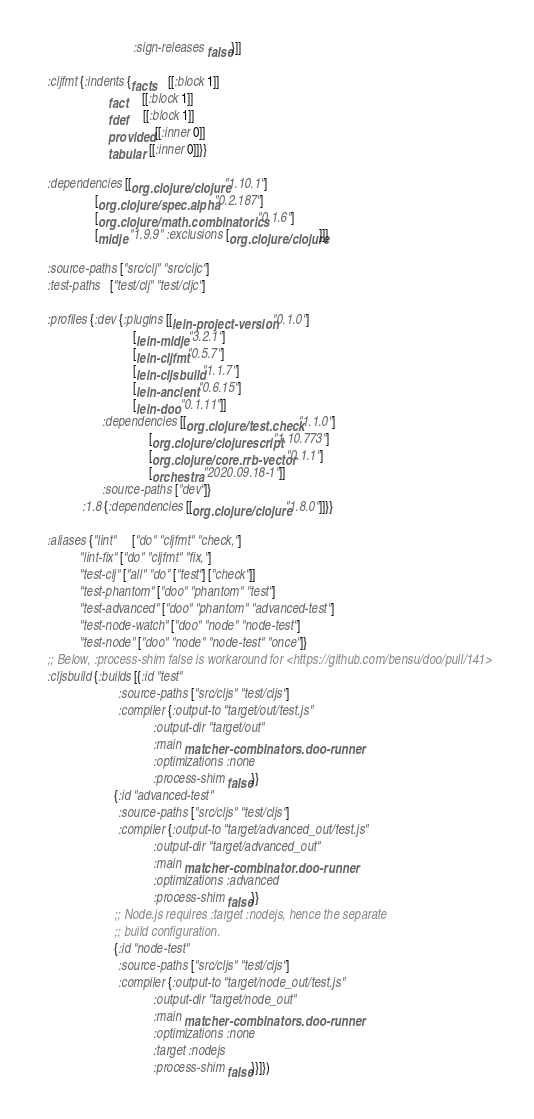Convert code to text. <code><loc_0><loc_0><loc_500><loc_500><_Clojure_>                             :sign-releases false}]]

  :cljfmt {:indents {facts    [[:block 1]]
                     fact     [[:block 1]]
                     fdef     [[:block 1]]
                     provided [[:inner 0]]
                     tabular  [[:inner 0]]}}

  :dependencies [[org.clojure/clojure "1.10.1"]
                 [org.clojure/spec.alpha "0.2.187"]
                 [org.clojure/math.combinatorics "0.1.6"]
                 [midje "1.9.9" :exclusions [org.clojure/clojure]]]

  :source-paths ["src/clj" "src/cljc"]
  :test-paths   ["test/clj" "test/cljc"]

  :profiles {:dev {:plugins [[lein-project-version "0.1.0"]
                             [lein-midje "3.2.1"]
                             [lein-cljfmt "0.5.7"]
                             [lein-cljsbuild "1.1.7"]
                             [lein-ancient "0.6.15"]
                             [lein-doo "0.1.11"]]
                   :dependencies [[org.clojure/test.check "1.1.0"]
                                  [org.clojure/clojurescript "1.10.773"]
                                  [org.clojure/core.rrb-vector "0.1.1"]
                                  [orchestra "2020.09.18-1"]]
                   :source-paths ["dev"]}
             :1.8 {:dependencies [[org.clojure/clojure "1.8.0"]]}}

  :aliases {"lint"     ["do" "cljfmt" "check,"]
            "lint-fix" ["do" "cljfmt" "fix,"]
            "test-clj" ["all" "do" ["test"] ["check"]]
            "test-phantom" ["doo" "phantom" "test"]
            "test-advanced" ["doo" "phantom" "advanced-test"]
            "test-node-watch" ["doo" "node" "node-test"]
            "test-node" ["doo" "node" "node-test" "once"]}
  ;; Below, :process-shim false is workaround for <https://github.com/bensu/doo/pull/141>
  :cljsbuild {:builds [{:id "test"
                        :source-paths ["src/cljs" "test/cljs"]
                        :compiler {:output-to "target/out/test.js"
                                   :output-dir "target/out"
                                   :main matcher-combinators.doo-runner
                                   :optimizations :none
                                   :process-shim false}}
                       {:id "advanced-test"
                        :source-paths ["src/cljs" "test/cljs"]
                        :compiler {:output-to "target/advanced_out/test.js"
                                   :output-dir "target/advanced_out"
                                   :main matcher-combinator.doo-runner
                                   :optimizations :advanced
                                   :process-shim false}}
                       ;; Node.js requires :target :nodejs, hence the separate
                       ;; build configuration.
                       {:id "node-test"
                        :source-paths ["src/cljs" "test/cljs"]
                        :compiler {:output-to "target/node_out/test.js"
                                   :output-dir "target/node_out"
                                   :main matcher-combinators.doo-runner
                                   :optimizations :none
                                   :target :nodejs
                                   :process-shim false}}]})
</code> 